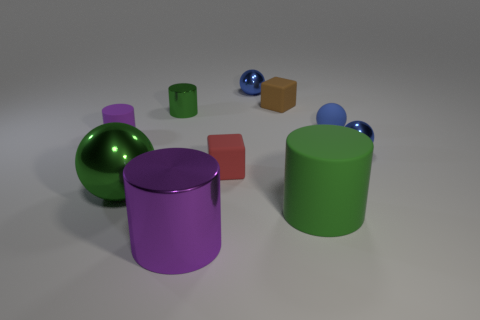Subtract all small matte cylinders. How many cylinders are left? 3 Subtract all gray spheres. How many green cylinders are left? 2 Subtract all green spheres. How many spheres are left? 3 Subtract 1 cylinders. How many cylinders are left? 3 Subtract all spheres. How many objects are left? 6 Add 5 green metallic cylinders. How many green metallic cylinders exist? 6 Subtract 0 cyan blocks. How many objects are left? 10 Subtract all blue blocks. Subtract all cyan spheres. How many blocks are left? 2 Subtract all green metal objects. Subtract all tiny rubber balls. How many objects are left? 7 Add 5 large green cylinders. How many large green cylinders are left? 6 